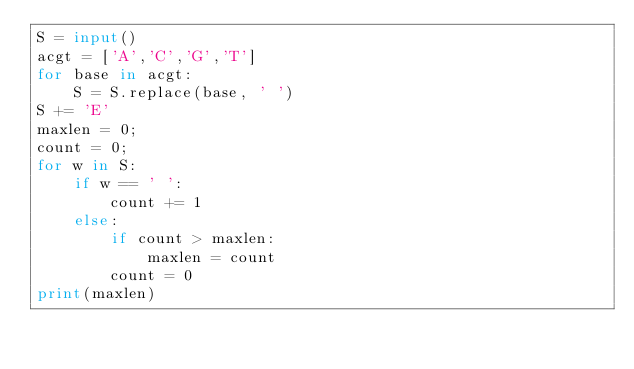Convert code to text. <code><loc_0><loc_0><loc_500><loc_500><_Python_>S = input()
acgt = ['A','C','G','T']
for base in acgt:
    S = S.replace(base, ' ')
S += 'E'
maxlen = 0;
count = 0;
for w in S:
    if w == ' ':
        count += 1
    else:
        if count > maxlen:
            maxlen = count
        count = 0
print(maxlen)</code> 